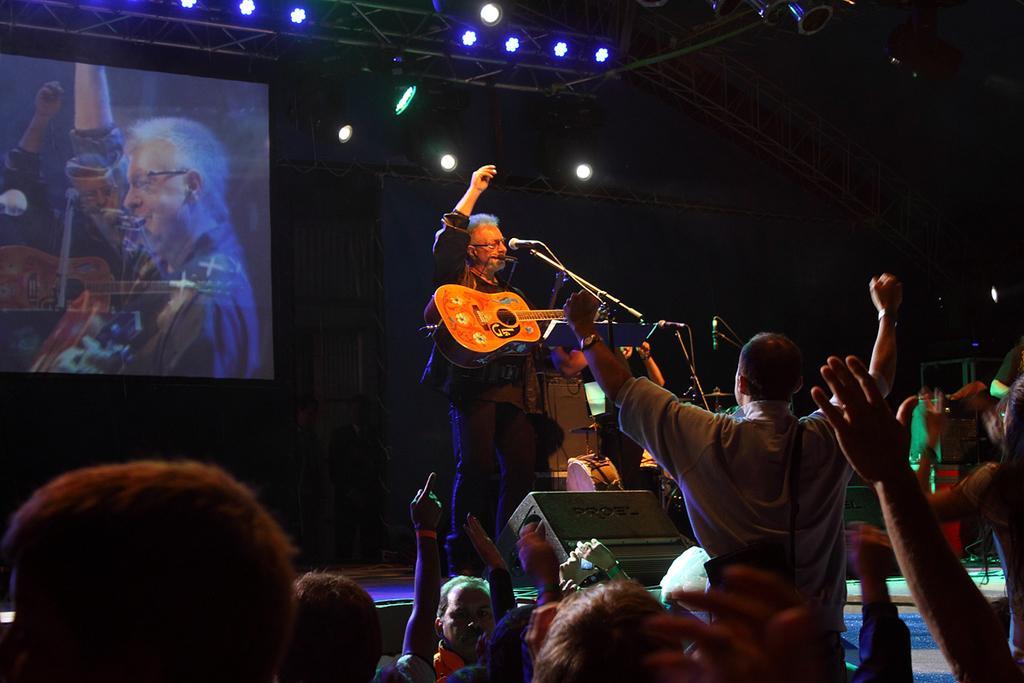Describe this image in one or two sentences. In the image there were group of people in the bottom facing towards the stage. A person is performing on the stage, he is holding a guitar and singing on a mike. To the left there is a screen and there is a person in it. In the top there were some lights. All the people were cheering to that singer. 